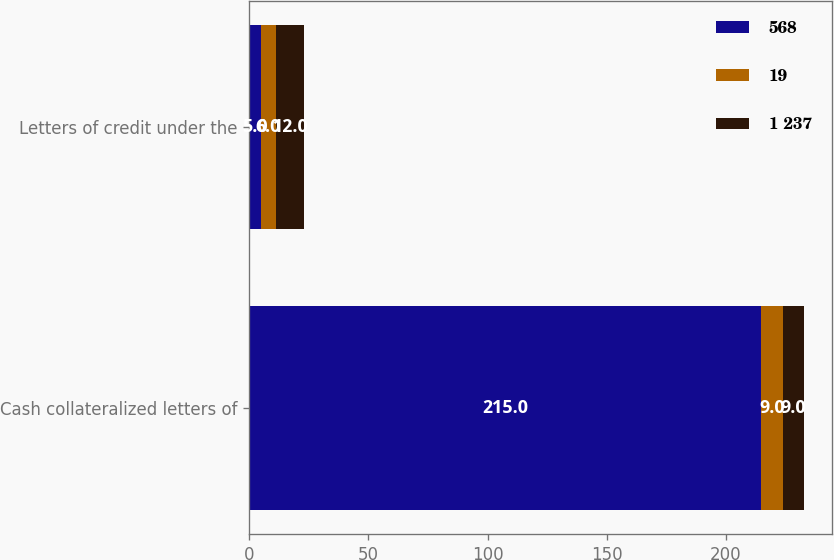<chart> <loc_0><loc_0><loc_500><loc_500><stacked_bar_chart><ecel><fcel>Cash collateralized letters of<fcel>Letters of credit under the<nl><fcel>568<fcel>215<fcel>5<nl><fcel>19<fcel>9<fcel>6<nl><fcel>1 237<fcel>9<fcel>12<nl></chart> 